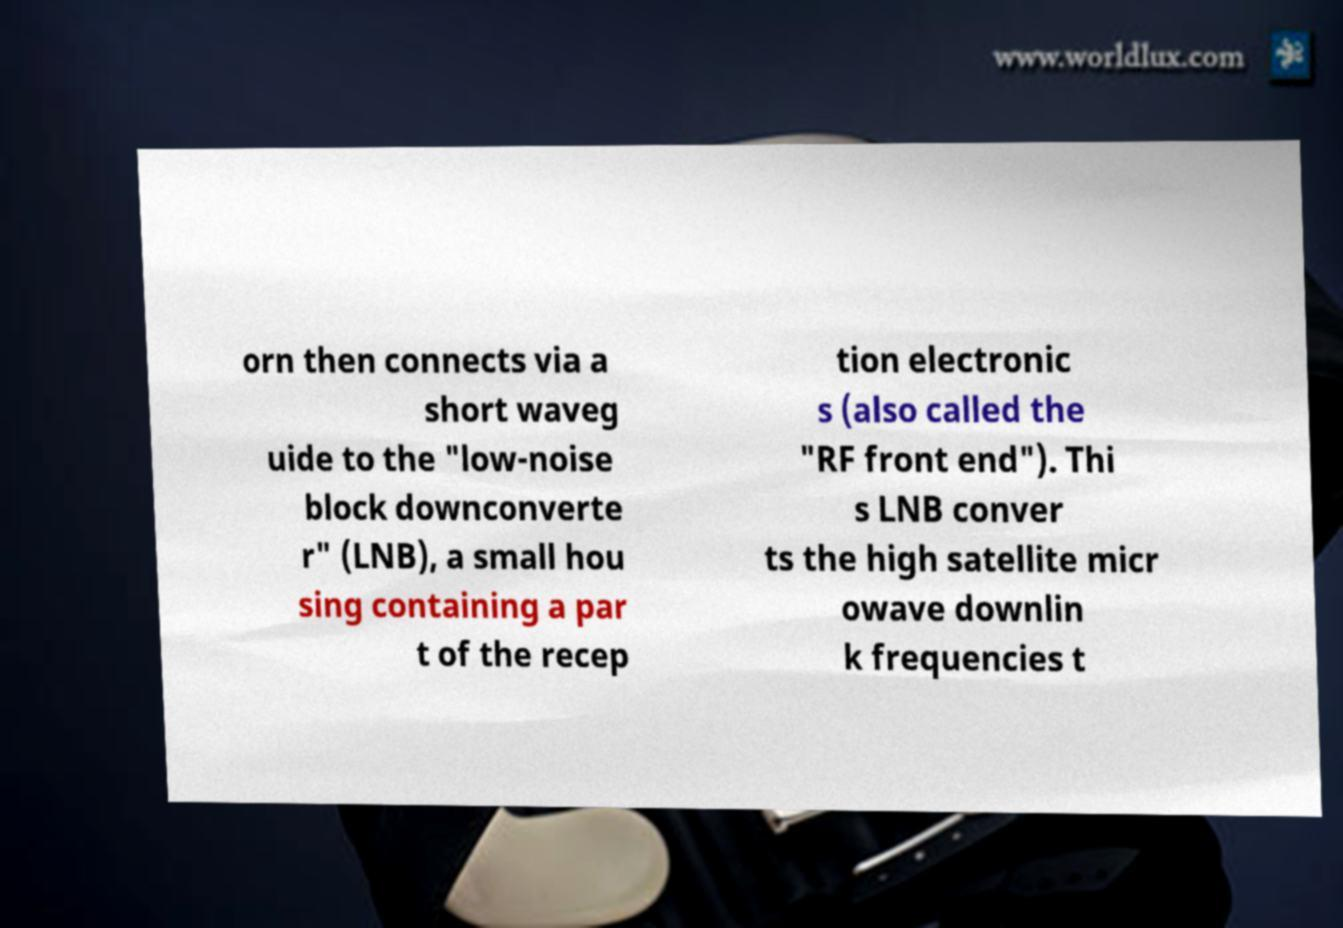What messages or text are displayed in this image? I need them in a readable, typed format. orn then connects via a short waveg uide to the "low-noise block downconverte r" (LNB), a small hou sing containing a par t of the recep tion electronic s (also called the "RF front end"). Thi s LNB conver ts the high satellite micr owave downlin k frequencies t 